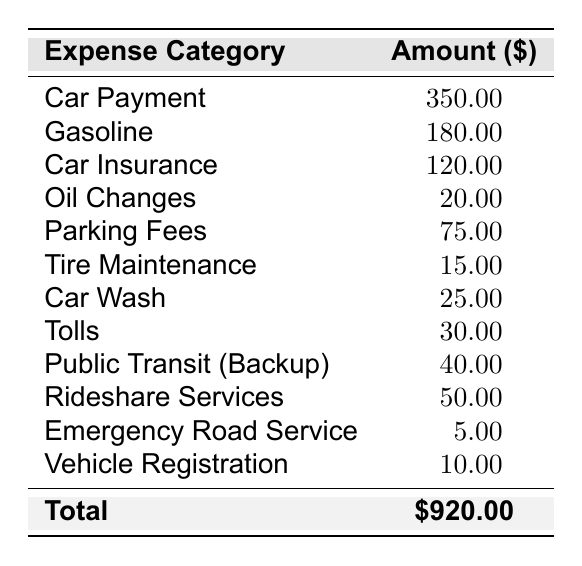What is the total amount spent on transportation? The table provides a total at the bottom, which shows the total amount of all expenses combined as \$920.00.
Answer: \$920.00 How much is spent on gasoline? The table lists the gasoline expense separately at \$180.00, making it easy to retrieve the exact amount.
Answer: \$180.00 Is the car payment the highest transportation cost? By comparing all amounts in the table, the car payment is listed at \$350.00, which is higher than all other individual expenses, confirming it as the highest.
Answer: Yes What is the combined amount spent on parking fees and tolls? To find the combined amount, add the parking fees (\$75.00) and tolls (\$30.00): \$75.00 + \$30.00 = \$105.00.
Answer: \$105.00 How much more is spent on car insurance than on oil changes? The car insurance is \$120.00 and the oil changes are \$20.00. The difference is calculated as \$120.00 - \$20.00 = \$100.00.
Answer: \$100.00 What are the total expenses for vehicle maintenance categories (oil changes, tire maintenance, and car wash)? The total for these categories is calculated by adding oil changes (\$20.00), tire maintenance (\$15.00), and car wash (\$25.00): \$20.00 + \$15.00 + \$25.00 = \$60.00.
Answer: \$60.00 What is the average cost of the listed expenses? There are 12 expense categories. First, sum all expenses to get \$920.00. Then divide by the number of categories: \$920.00 / 12 = \$76.67.
Answer: \$76.67 Which expense category has the lowest cost? The table lists several costs, and the lowest amount shown is \$5.00 for emergency road service, making it the least expensive category.
Answer: Emergency Road Service How much is spent on rideshare services compared to public transit? Rideshare services cost \$50.00 and public transit costs \$40.00. The difference is \$50.00 - \$40.00 = \$10.00, meaning rideshare costs \$10.00 more.
Answer: \$10.00 If the gasoline expense increased by 10%, what would the new cost be? The original gasoline cost is \$180.00, and a 10% increase would be \$180.00 * 0.10 = \$18.00. Adding that gives \$180.00 + \$18.00 = \$198.00.
Answer: \$198.00 